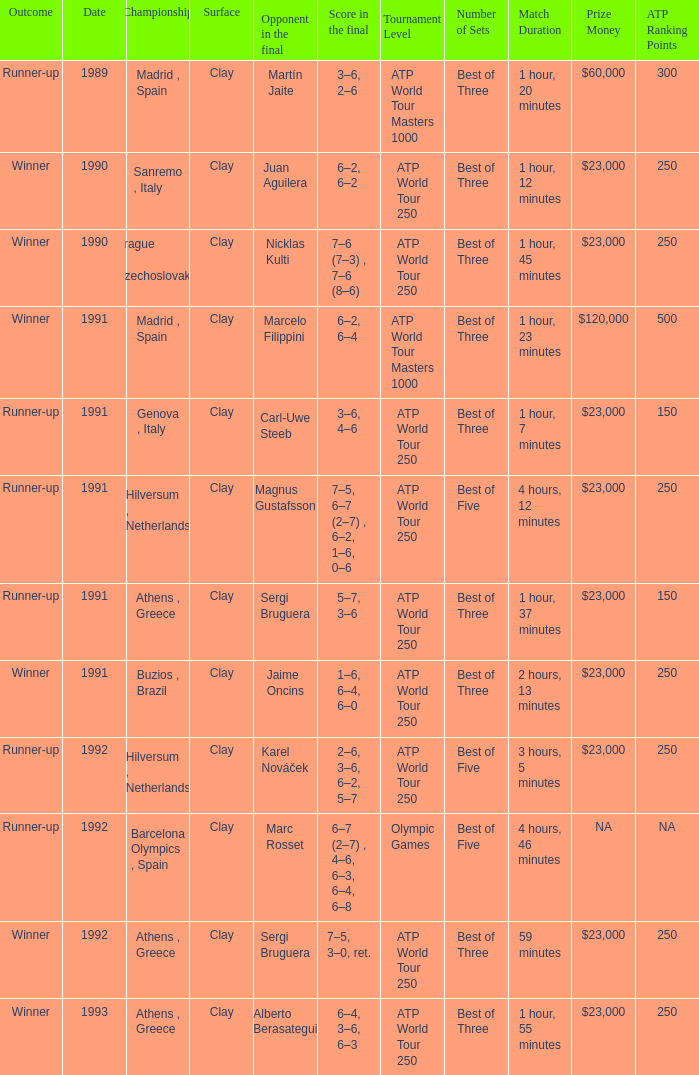What is Opponent In The Final, when Date is before 1991, and when Outcome is "Runner-Up"? Martín Jaite. 